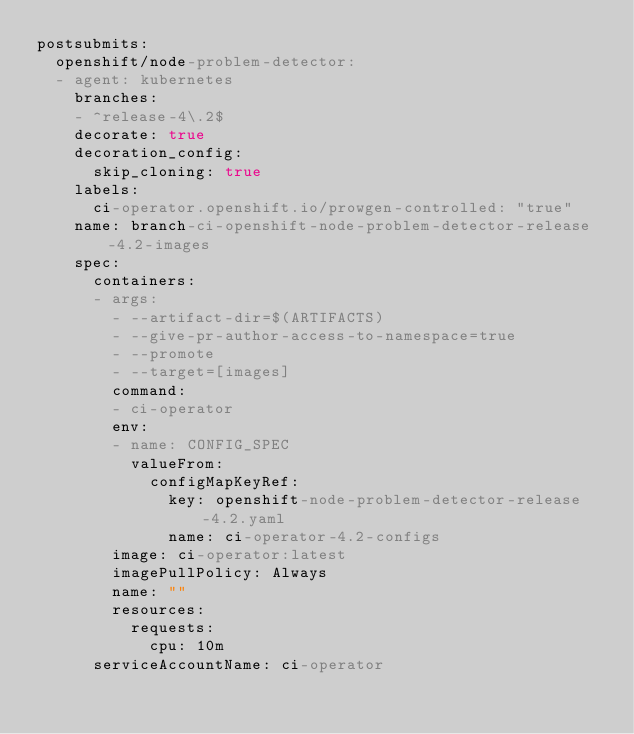Convert code to text. <code><loc_0><loc_0><loc_500><loc_500><_YAML_>postsubmits:
  openshift/node-problem-detector:
  - agent: kubernetes
    branches:
    - ^release-4\.2$
    decorate: true
    decoration_config:
      skip_cloning: true
    labels:
      ci-operator.openshift.io/prowgen-controlled: "true"
    name: branch-ci-openshift-node-problem-detector-release-4.2-images
    spec:
      containers:
      - args:
        - --artifact-dir=$(ARTIFACTS)
        - --give-pr-author-access-to-namespace=true
        - --promote
        - --target=[images]
        command:
        - ci-operator
        env:
        - name: CONFIG_SPEC
          valueFrom:
            configMapKeyRef:
              key: openshift-node-problem-detector-release-4.2.yaml
              name: ci-operator-4.2-configs
        image: ci-operator:latest
        imagePullPolicy: Always
        name: ""
        resources:
          requests:
            cpu: 10m
      serviceAccountName: ci-operator
</code> 